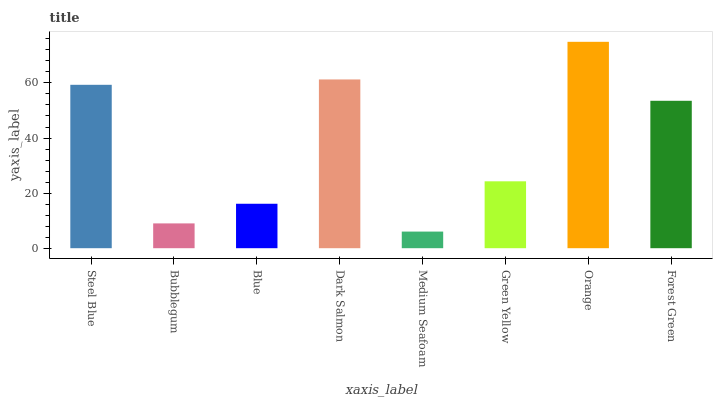Is Medium Seafoam the minimum?
Answer yes or no. Yes. Is Orange the maximum?
Answer yes or no. Yes. Is Bubblegum the minimum?
Answer yes or no. No. Is Bubblegum the maximum?
Answer yes or no. No. Is Steel Blue greater than Bubblegum?
Answer yes or no. Yes. Is Bubblegum less than Steel Blue?
Answer yes or no. Yes. Is Bubblegum greater than Steel Blue?
Answer yes or no. No. Is Steel Blue less than Bubblegum?
Answer yes or no. No. Is Forest Green the high median?
Answer yes or no. Yes. Is Green Yellow the low median?
Answer yes or no. Yes. Is Blue the high median?
Answer yes or no. No. Is Medium Seafoam the low median?
Answer yes or no. No. 